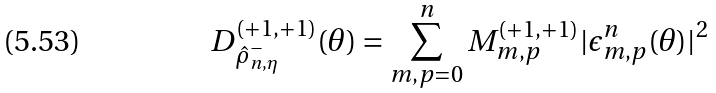Convert formula to latex. <formula><loc_0><loc_0><loc_500><loc_500>D _ { \hat { \rho } _ { n , \eta } ^ { - } } ^ { ( + 1 , + 1 ) } ( \theta ) = \sum _ { m , p = 0 } ^ { n } M ^ { ( + 1 , + 1 ) } _ { m , p } | \epsilon _ { m , p } ^ { n } ( \theta ) | ^ { 2 }</formula> 